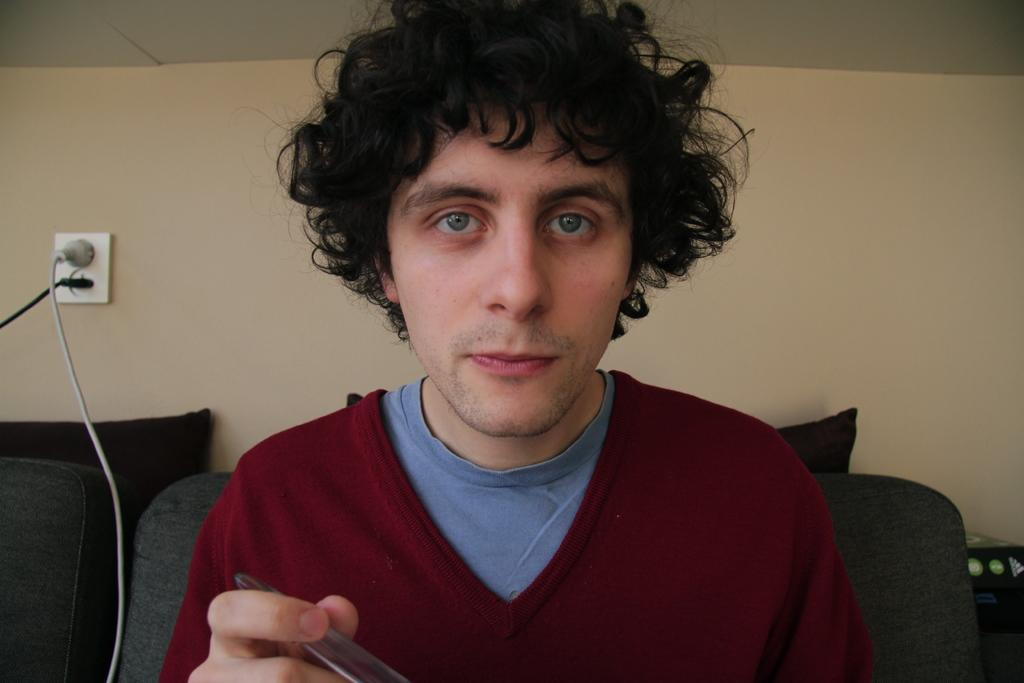What can be seen in the image? There is a person in the image. What is the person holding? The person is holding something, but we cannot determine what it is from the facts provided. How is the person dressed? The person is wearing a maroon and blue color dress. What is visible in the background of the image? There is a couch in the background of the image, and the wall is cream-colored. What can be found on the couch? There are pillows on the couch. How many lizards are crawling on the person's dress in the image? There are no lizards present in the image; the person is wearing a maroon and blue color dress. 